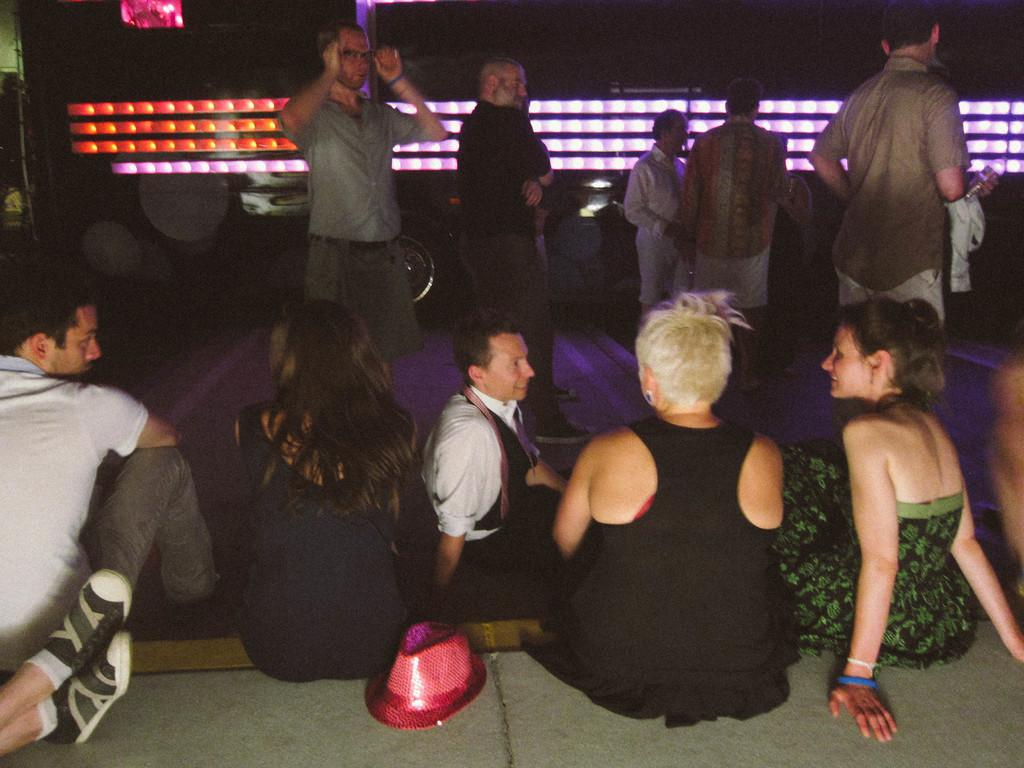What are the people in the image doing? The people in the image are standing in the center and sitting at the bottom. Can you describe any accessories worn by the people in the image? Yes, there is a hat visible in the image. What can be seen in the background of the image? There are lights in the background of the image. How many socks can be seen on the people in the image? There is no information about socks in the image, so it cannot be determined how many socks are visible. What type of arch is present in the image? There is no arch present in the image. 